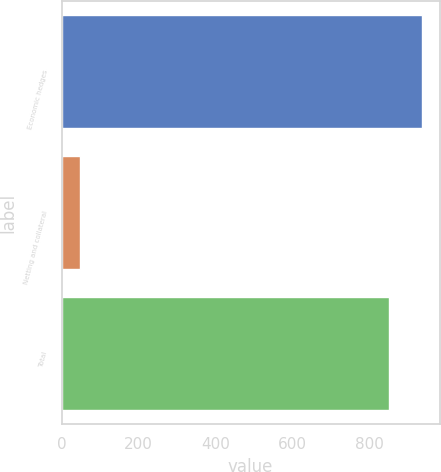<chart> <loc_0><loc_0><loc_500><loc_500><bar_chart><fcel>Economic hedges<fcel>Netting and collateral<fcel>Total<nl><fcel>936.1<fcel>47<fcel>851<nl></chart> 